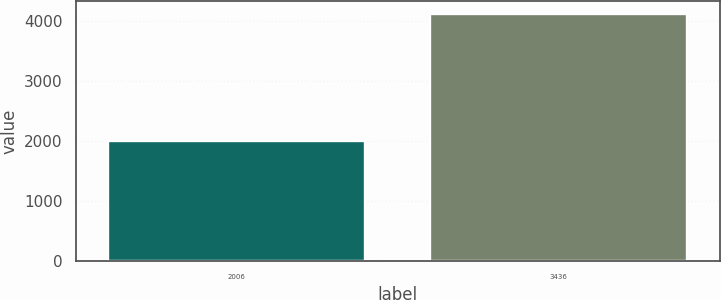Convert chart. <chart><loc_0><loc_0><loc_500><loc_500><bar_chart><fcel>2006<fcel>3436<nl><fcel>2003<fcel>4125<nl></chart> 